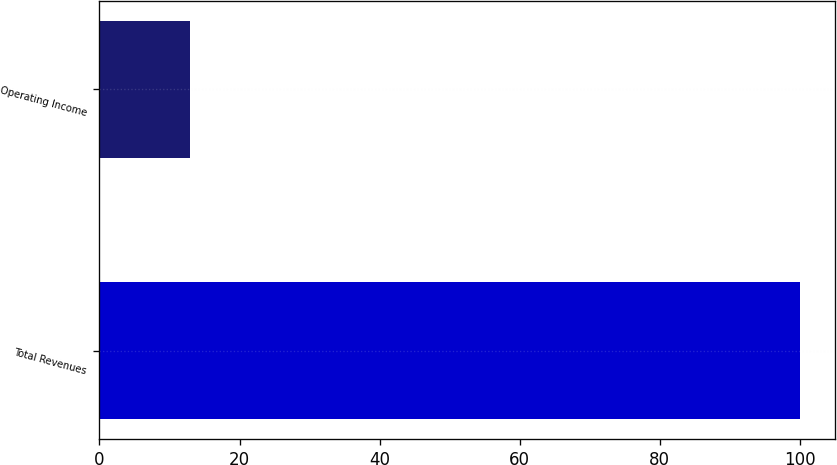Convert chart. <chart><loc_0><loc_0><loc_500><loc_500><bar_chart><fcel>Total Revenues<fcel>Operating Income<nl><fcel>100<fcel>13<nl></chart> 